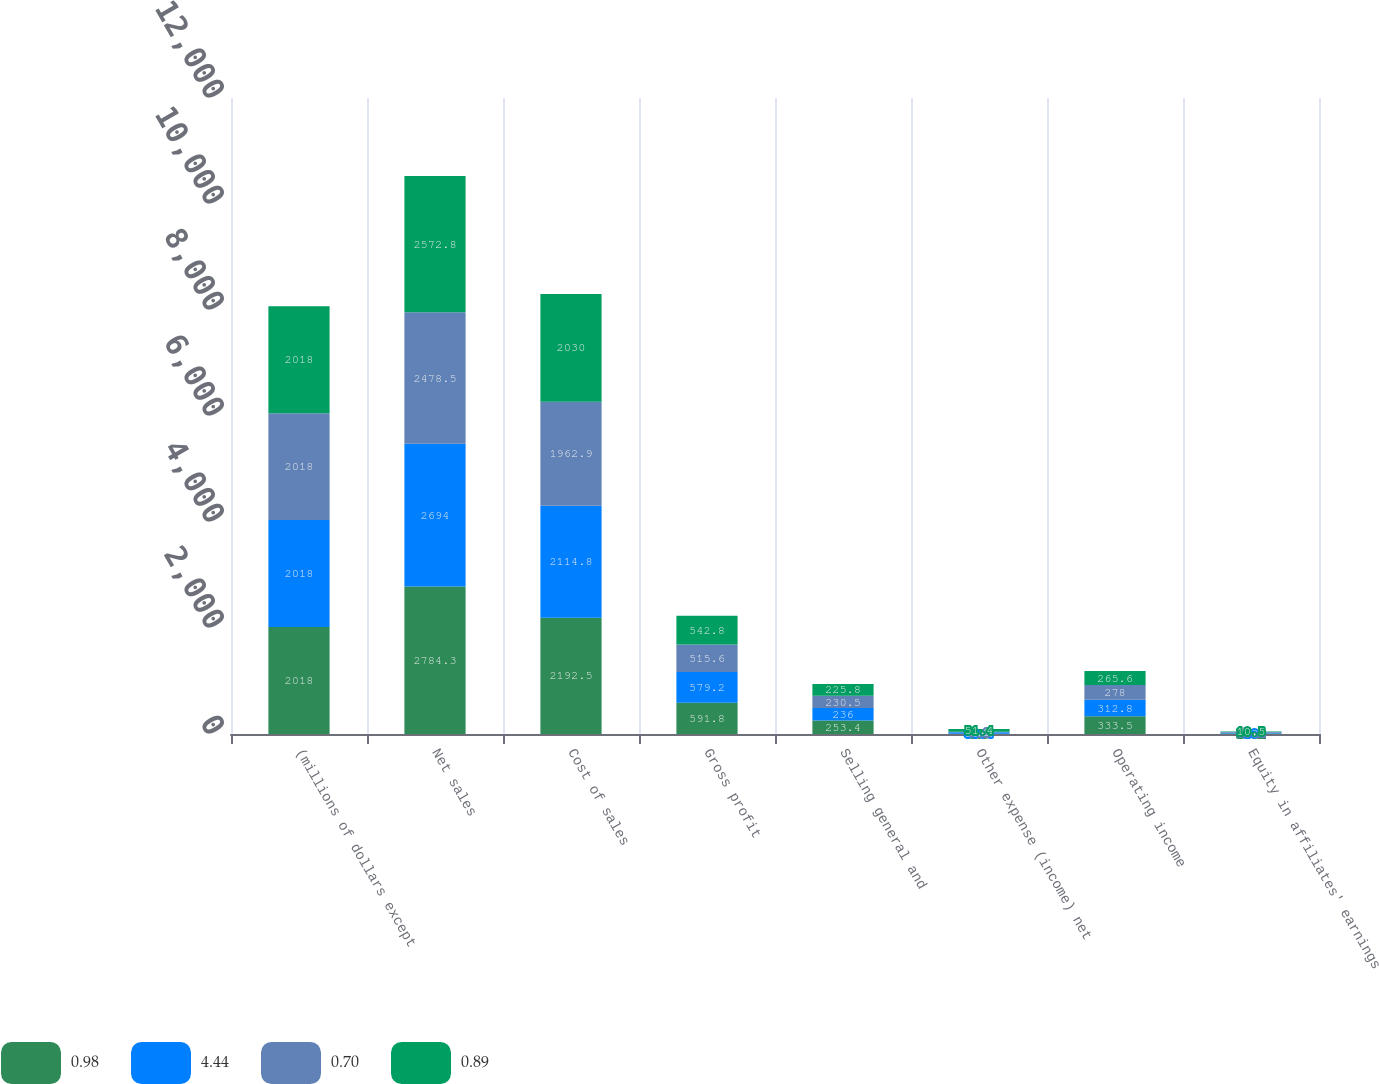Convert chart. <chart><loc_0><loc_0><loc_500><loc_500><stacked_bar_chart><ecel><fcel>(millions of dollars except<fcel>Net sales<fcel>Cost of sales<fcel>Gross profit<fcel>Selling general and<fcel>Other expense (income) net<fcel>Operating income<fcel>Equity in affiliates' earnings<nl><fcel>0.98<fcel>2018<fcel>2784.3<fcel>2192.5<fcel>591.8<fcel>253.4<fcel>4.9<fcel>333.5<fcel>10.2<nl><fcel>4.44<fcel>2018<fcel>2694<fcel>2114.8<fcel>579.2<fcel>236<fcel>30.4<fcel>312.8<fcel>13<nl><fcel>0.7<fcel>2018<fcel>2478.5<fcel>1962.9<fcel>515.6<fcel>230.5<fcel>7.1<fcel>278<fcel>15.2<nl><fcel>0.89<fcel>2018<fcel>2572.8<fcel>2030<fcel>542.8<fcel>225.8<fcel>51.4<fcel>265.6<fcel>10.5<nl></chart> 